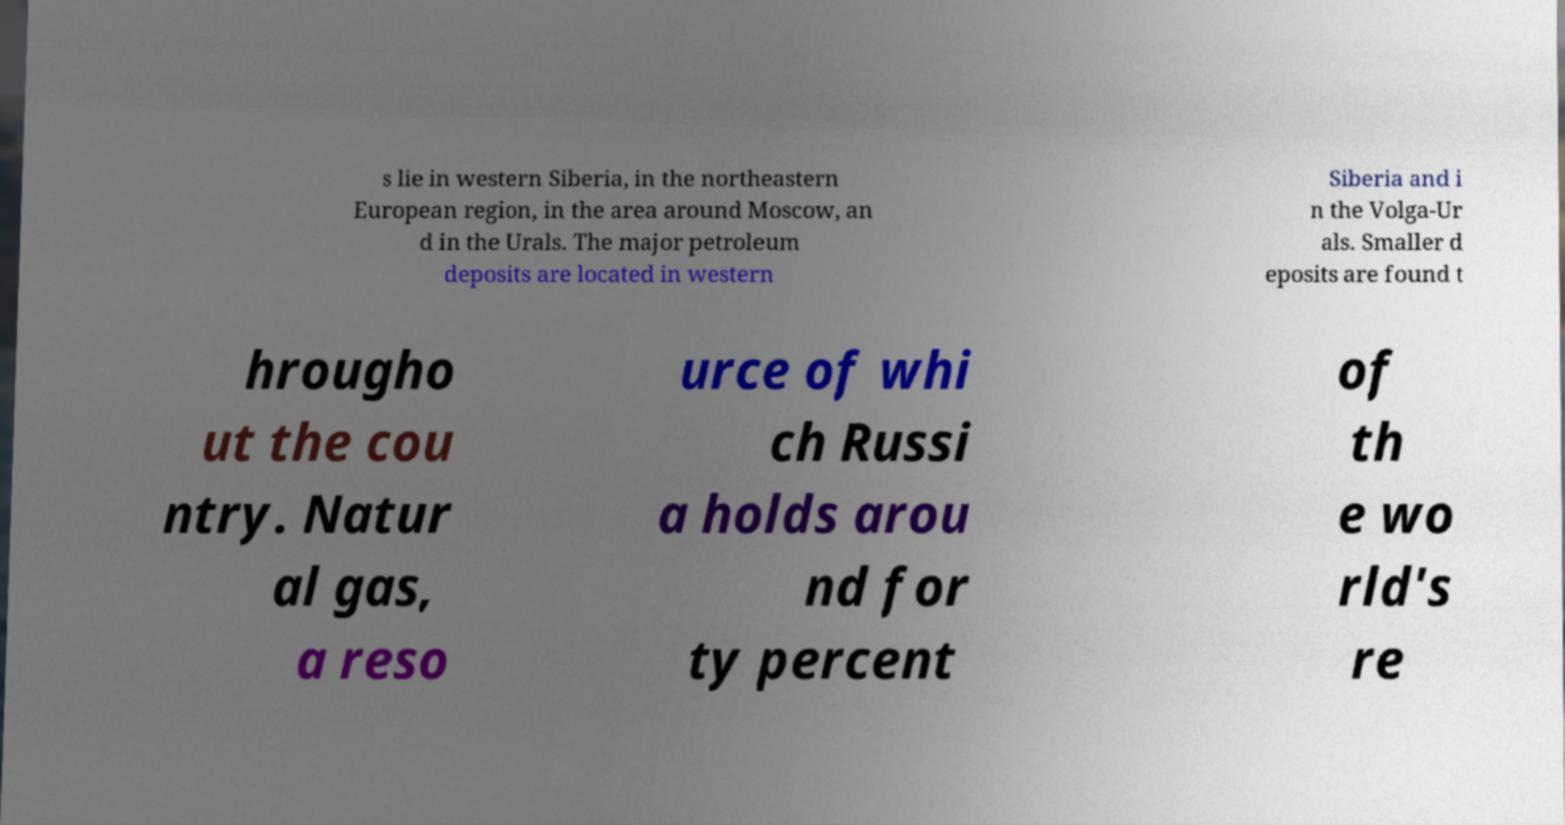I need the written content from this picture converted into text. Can you do that? s lie in western Siberia, in the northeastern European region, in the area around Moscow, an d in the Urals. The major petroleum deposits are located in western Siberia and i n the Volga-Ur als. Smaller d eposits are found t hrougho ut the cou ntry. Natur al gas, a reso urce of whi ch Russi a holds arou nd for ty percent of th e wo rld's re 